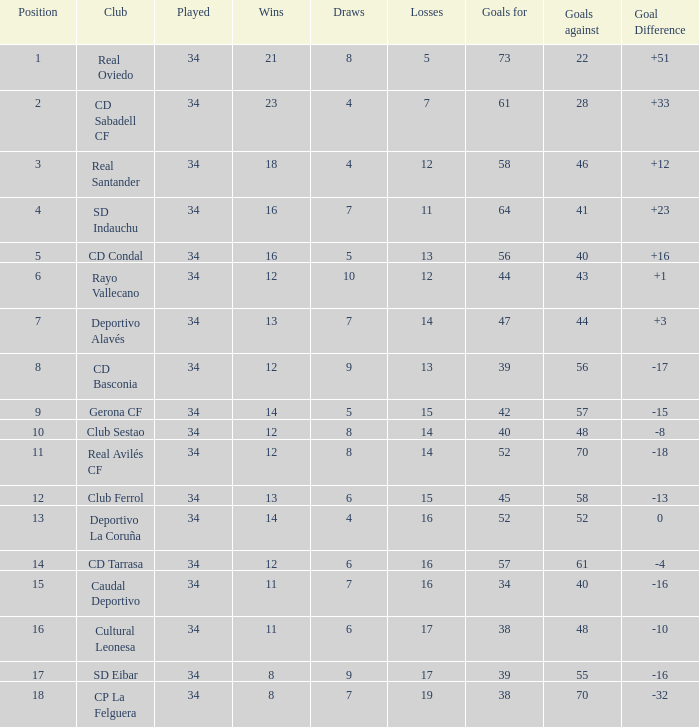Which Losses have a Goal Difference of -16, and less than 8 wins? None. 